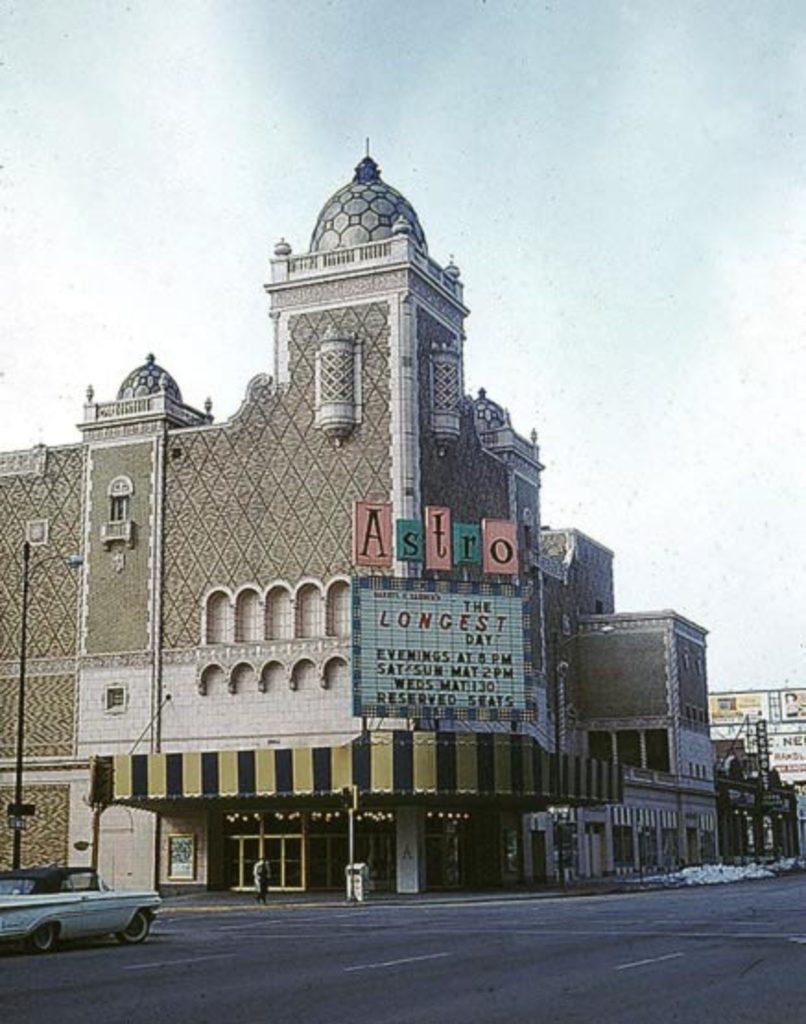Can you describe this image briefly? On the left side of the image we can see one car on the road. In the background, we can see the sky, clouds, buildings, banners, poles, fences, one person is standing and wearing a backpack and a few other objects.  